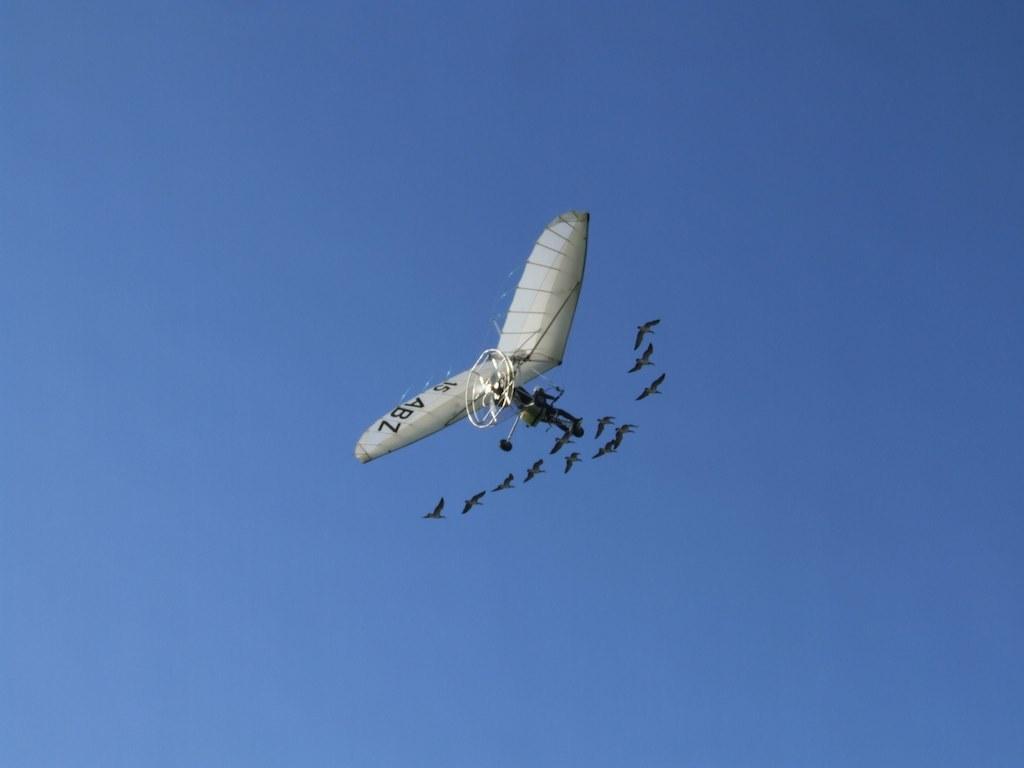What number is on the hang glider?
Ensure brevity in your answer.  15. What are the letters on the hangglider?
Provide a short and direct response. Abz. 